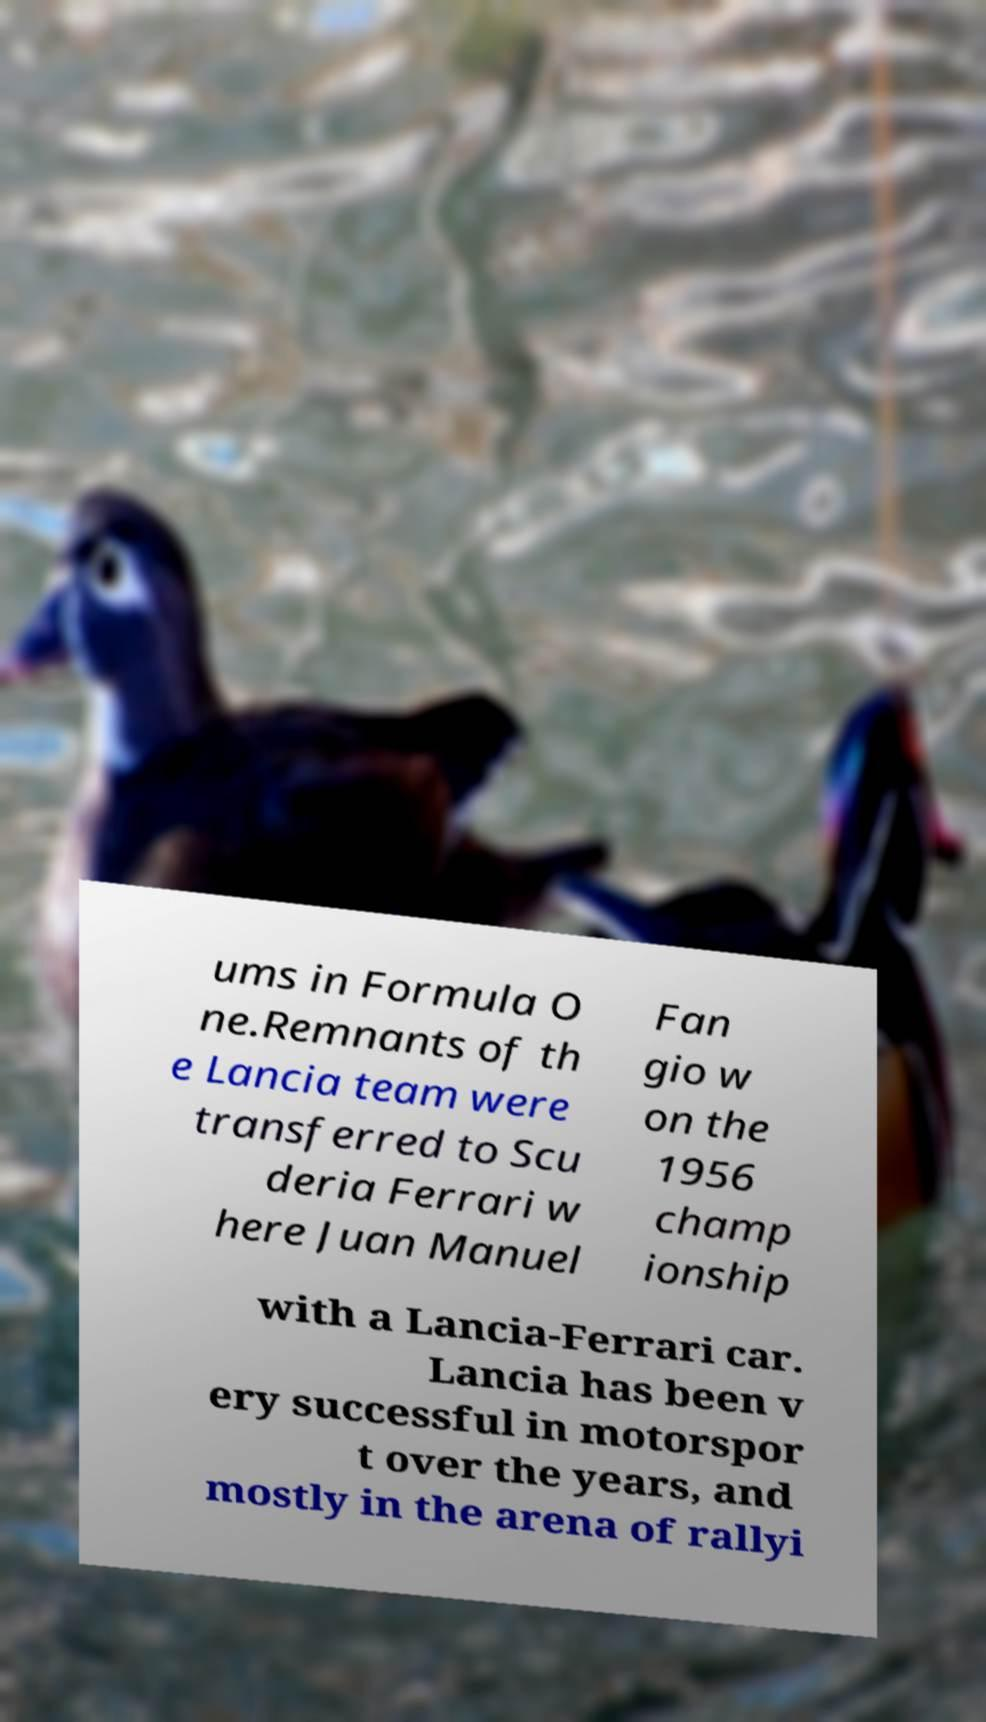Can you read and provide the text displayed in the image?This photo seems to have some interesting text. Can you extract and type it out for me? ums in Formula O ne.Remnants of th e Lancia team were transferred to Scu deria Ferrari w here Juan Manuel Fan gio w on the 1956 champ ionship with a Lancia-Ferrari car. Lancia has been v ery successful in motorspor t over the years, and mostly in the arena of rallyi 